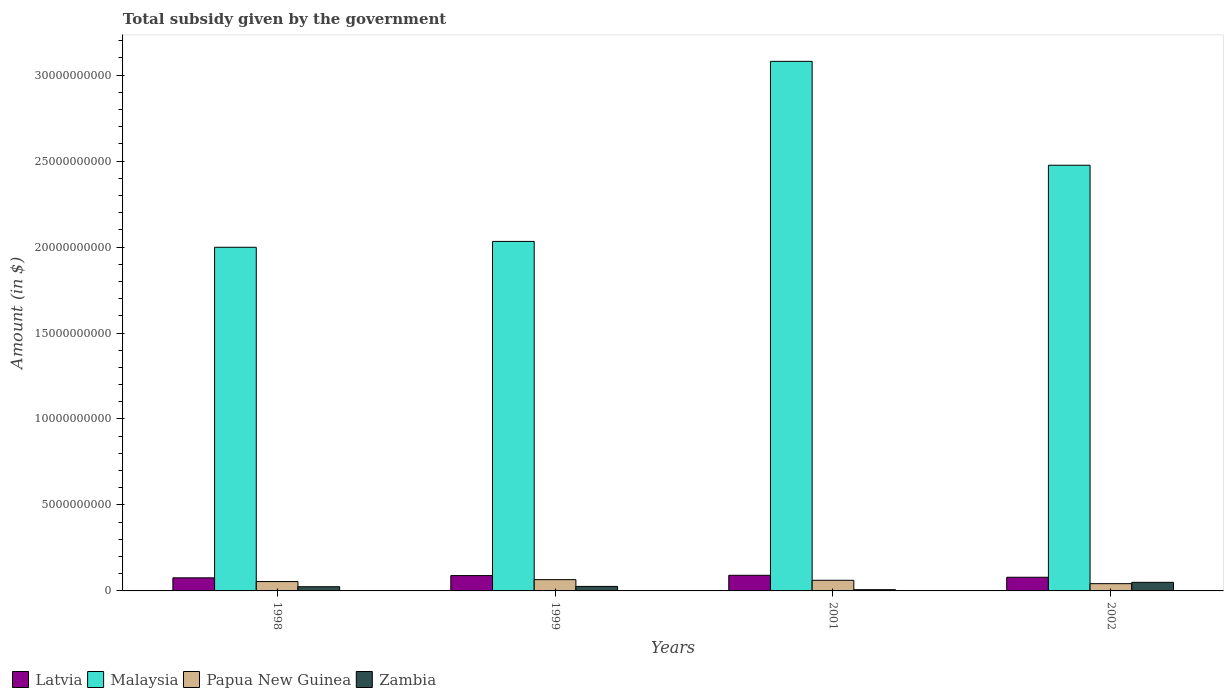How many different coloured bars are there?
Provide a succinct answer. 4. Are the number of bars per tick equal to the number of legend labels?
Ensure brevity in your answer.  Yes. In how many cases, is the number of bars for a given year not equal to the number of legend labels?
Your response must be concise. 0. What is the total revenue collected by the government in Latvia in 2002?
Offer a very short reply. 7.95e+08. Across all years, what is the maximum total revenue collected by the government in Malaysia?
Your answer should be very brief. 3.08e+1. Across all years, what is the minimum total revenue collected by the government in Zambia?
Offer a terse response. 7.21e+07. In which year was the total revenue collected by the government in Papua New Guinea maximum?
Offer a terse response. 1999. What is the total total revenue collected by the government in Malaysia in the graph?
Keep it short and to the point. 9.59e+1. What is the difference between the total revenue collected by the government in Papua New Guinea in 1999 and that in 2002?
Ensure brevity in your answer.  2.33e+08. What is the difference between the total revenue collected by the government in Latvia in 2002 and the total revenue collected by the government in Zambia in 1999?
Provide a succinct answer. 5.34e+08. What is the average total revenue collected by the government in Latvia per year?
Give a very brief answer. 8.39e+08. In the year 1999, what is the difference between the total revenue collected by the government in Malaysia and total revenue collected by the government in Papua New Guinea?
Make the answer very short. 1.97e+1. What is the ratio of the total revenue collected by the government in Malaysia in 1998 to that in 2002?
Your response must be concise. 0.81. Is the total revenue collected by the government in Latvia in 1998 less than that in 2001?
Make the answer very short. Yes. Is the difference between the total revenue collected by the government in Malaysia in 2001 and 2002 greater than the difference between the total revenue collected by the government in Papua New Guinea in 2001 and 2002?
Offer a terse response. Yes. What is the difference between the highest and the second highest total revenue collected by the government in Malaysia?
Provide a short and direct response. 6.04e+09. What is the difference between the highest and the lowest total revenue collected by the government in Papua New Guinea?
Make the answer very short. 2.33e+08. In how many years, is the total revenue collected by the government in Papua New Guinea greater than the average total revenue collected by the government in Papua New Guinea taken over all years?
Offer a very short reply. 2. What does the 3rd bar from the left in 2001 represents?
Your answer should be very brief. Papua New Guinea. What does the 4th bar from the right in 2002 represents?
Your answer should be compact. Latvia. Is it the case that in every year, the sum of the total revenue collected by the government in Latvia and total revenue collected by the government in Malaysia is greater than the total revenue collected by the government in Papua New Guinea?
Provide a short and direct response. Yes. How many bars are there?
Provide a succinct answer. 16. Are all the bars in the graph horizontal?
Provide a short and direct response. No. Does the graph contain any zero values?
Provide a succinct answer. No. Where does the legend appear in the graph?
Keep it short and to the point. Bottom left. What is the title of the graph?
Your answer should be very brief. Total subsidy given by the government. What is the label or title of the Y-axis?
Your response must be concise. Amount (in $). What is the Amount (in $) of Latvia in 1998?
Offer a terse response. 7.61e+08. What is the Amount (in $) of Malaysia in 1998?
Keep it short and to the point. 2.00e+1. What is the Amount (in $) of Papua New Guinea in 1998?
Keep it short and to the point. 5.45e+08. What is the Amount (in $) of Zambia in 1998?
Give a very brief answer. 2.44e+08. What is the Amount (in $) in Latvia in 1999?
Offer a very short reply. 8.92e+08. What is the Amount (in $) in Malaysia in 1999?
Your answer should be compact. 2.03e+1. What is the Amount (in $) in Papua New Guinea in 1999?
Your answer should be very brief. 6.56e+08. What is the Amount (in $) of Zambia in 1999?
Give a very brief answer. 2.62e+08. What is the Amount (in $) of Latvia in 2001?
Offer a terse response. 9.09e+08. What is the Amount (in $) of Malaysia in 2001?
Offer a terse response. 3.08e+1. What is the Amount (in $) of Papua New Guinea in 2001?
Keep it short and to the point. 6.18e+08. What is the Amount (in $) in Zambia in 2001?
Keep it short and to the point. 7.21e+07. What is the Amount (in $) in Latvia in 2002?
Offer a very short reply. 7.95e+08. What is the Amount (in $) in Malaysia in 2002?
Ensure brevity in your answer.  2.48e+1. What is the Amount (in $) of Papua New Guinea in 2002?
Give a very brief answer. 4.22e+08. What is the Amount (in $) in Zambia in 2002?
Your answer should be compact. 4.99e+08. Across all years, what is the maximum Amount (in $) of Latvia?
Keep it short and to the point. 9.09e+08. Across all years, what is the maximum Amount (in $) of Malaysia?
Offer a terse response. 3.08e+1. Across all years, what is the maximum Amount (in $) of Papua New Guinea?
Keep it short and to the point. 6.56e+08. Across all years, what is the maximum Amount (in $) in Zambia?
Ensure brevity in your answer.  4.99e+08. Across all years, what is the minimum Amount (in $) of Latvia?
Your response must be concise. 7.61e+08. Across all years, what is the minimum Amount (in $) in Malaysia?
Your response must be concise. 2.00e+1. Across all years, what is the minimum Amount (in $) in Papua New Guinea?
Offer a very short reply. 4.22e+08. Across all years, what is the minimum Amount (in $) of Zambia?
Make the answer very short. 7.21e+07. What is the total Amount (in $) of Latvia in the graph?
Your answer should be compact. 3.36e+09. What is the total Amount (in $) of Malaysia in the graph?
Your answer should be very brief. 9.59e+1. What is the total Amount (in $) in Papua New Guinea in the graph?
Keep it short and to the point. 2.24e+09. What is the total Amount (in $) of Zambia in the graph?
Your response must be concise. 1.08e+09. What is the difference between the Amount (in $) of Latvia in 1998 and that in 1999?
Ensure brevity in your answer.  -1.31e+08. What is the difference between the Amount (in $) of Malaysia in 1998 and that in 1999?
Give a very brief answer. -3.41e+08. What is the difference between the Amount (in $) in Papua New Guinea in 1998 and that in 1999?
Provide a short and direct response. -1.11e+08. What is the difference between the Amount (in $) of Zambia in 1998 and that in 1999?
Offer a terse response. -1.76e+07. What is the difference between the Amount (in $) in Latvia in 1998 and that in 2001?
Your answer should be very brief. -1.49e+08. What is the difference between the Amount (in $) of Malaysia in 1998 and that in 2001?
Provide a succinct answer. -1.08e+1. What is the difference between the Amount (in $) of Papua New Guinea in 1998 and that in 2001?
Your answer should be compact. -7.33e+07. What is the difference between the Amount (in $) of Zambia in 1998 and that in 2001?
Keep it short and to the point. 1.72e+08. What is the difference between the Amount (in $) of Latvia in 1998 and that in 2002?
Your answer should be compact. -3.44e+07. What is the difference between the Amount (in $) of Malaysia in 1998 and that in 2002?
Offer a terse response. -4.77e+09. What is the difference between the Amount (in $) of Papua New Guinea in 1998 and that in 2002?
Keep it short and to the point. 1.23e+08. What is the difference between the Amount (in $) in Zambia in 1998 and that in 2002?
Offer a very short reply. -2.55e+08. What is the difference between the Amount (in $) of Latvia in 1999 and that in 2001?
Provide a succinct answer. -1.75e+07. What is the difference between the Amount (in $) in Malaysia in 1999 and that in 2001?
Offer a terse response. -1.05e+1. What is the difference between the Amount (in $) in Papua New Guinea in 1999 and that in 2001?
Offer a terse response. 3.73e+07. What is the difference between the Amount (in $) of Zambia in 1999 and that in 2001?
Your response must be concise. 1.89e+08. What is the difference between the Amount (in $) of Latvia in 1999 and that in 2002?
Give a very brief answer. 9.67e+07. What is the difference between the Amount (in $) in Malaysia in 1999 and that in 2002?
Ensure brevity in your answer.  -4.43e+09. What is the difference between the Amount (in $) of Papua New Guinea in 1999 and that in 2002?
Give a very brief answer. 2.33e+08. What is the difference between the Amount (in $) of Zambia in 1999 and that in 2002?
Your answer should be compact. -2.38e+08. What is the difference between the Amount (in $) in Latvia in 2001 and that in 2002?
Offer a terse response. 1.14e+08. What is the difference between the Amount (in $) in Malaysia in 2001 and that in 2002?
Your answer should be very brief. 6.04e+09. What is the difference between the Amount (in $) in Papua New Guinea in 2001 and that in 2002?
Your response must be concise. 1.96e+08. What is the difference between the Amount (in $) in Zambia in 2001 and that in 2002?
Your answer should be compact. -4.27e+08. What is the difference between the Amount (in $) of Latvia in 1998 and the Amount (in $) of Malaysia in 1999?
Ensure brevity in your answer.  -1.96e+1. What is the difference between the Amount (in $) of Latvia in 1998 and the Amount (in $) of Papua New Guinea in 1999?
Provide a short and direct response. 1.05e+08. What is the difference between the Amount (in $) of Latvia in 1998 and the Amount (in $) of Zambia in 1999?
Make the answer very short. 4.99e+08. What is the difference between the Amount (in $) of Malaysia in 1998 and the Amount (in $) of Papua New Guinea in 1999?
Keep it short and to the point. 1.93e+1. What is the difference between the Amount (in $) of Malaysia in 1998 and the Amount (in $) of Zambia in 1999?
Provide a short and direct response. 1.97e+1. What is the difference between the Amount (in $) of Papua New Guinea in 1998 and the Amount (in $) of Zambia in 1999?
Your response must be concise. 2.84e+08. What is the difference between the Amount (in $) of Latvia in 1998 and the Amount (in $) of Malaysia in 2001?
Ensure brevity in your answer.  -3.00e+1. What is the difference between the Amount (in $) in Latvia in 1998 and the Amount (in $) in Papua New Guinea in 2001?
Keep it short and to the point. 1.42e+08. What is the difference between the Amount (in $) of Latvia in 1998 and the Amount (in $) of Zambia in 2001?
Your answer should be compact. 6.89e+08. What is the difference between the Amount (in $) of Malaysia in 1998 and the Amount (in $) of Papua New Guinea in 2001?
Your response must be concise. 1.94e+1. What is the difference between the Amount (in $) in Malaysia in 1998 and the Amount (in $) in Zambia in 2001?
Provide a short and direct response. 1.99e+1. What is the difference between the Amount (in $) in Papua New Guinea in 1998 and the Amount (in $) in Zambia in 2001?
Make the answer very short. 4.73e+08. What is the difference between the Amount (in $) of Latvia in 1998 and the Amount (in $) of Malaysia in 2002?
Make the answer very short. -2.40e+1. What is the difference between the Amount (in $) of Latvia in 1998 and the Amount (in $) of Papua New Guinea in 2002?
Keep it short and to the point. 3.38e+08. What is the difference between the Amount (in $) in Latvia in 1998 and the Amount (in $) in Zambia in 2002?
Your response must be concise. 2.61e+08. What is the difference between the Amount (in $) of Malaysia in 1998 and the Amount (in $) of Papua New Guinea in 2002?
Keep it short and to the point. 1.96e+1. What is the difference between the Amount (in $) of Malaysia in 1998 and the Amount (in $) of Zambia in 2002?
Provide a succinct answer. 1.95e+1. What is the difference between the Amount (in $) of Papua New Guinea in 1998 and the Amount (in $) of Zambia in 2002?
Keep it short and to the point. 4.58e+07. What is the difference between the Amount (in $) of Latvia in 1999 and the Amount (in $) of Malaysia in 2001?
Ensure brevity in your answer.  -2.99e+1. What is the difference between the Amount (in $) of Latvia in 1999 and the Amount (in $) of Papua New Guinea in 2001?
Offer a very short reply. 2.73e+08. What is the difference between the Amount (in $) of Latvia in 1999 and the Amount (in $) of Zambia in 2001?
Make the answer very short. 8.20e+08. What is the difference between the Amount (in $) in Malaysia in 1999 and the Amount (in $) in Papua New Guinea in 2001?
Ensure brevity in your answer.  1.97e+1. What is the difference between the Amount (in $) in Malaysia in 1999 and the Amount (in $) in Zambia in 2001?
Offer a terse response. 2.03e+1. What is the difference between the Amount (in $) of Papua New Guinea in 1999 and the Amount (in $) of Zambia in 2001?
Offer a terse response. 5.84e+08. What is the difference between the Amount (in $) of Latvia in 1999 and the Amount (in $) of Malaysia in 2002?
Make the answer very short. -2.39e+1. What is the difference between the Amount (in $) of Latvia in 1999 and the Amount (in $) of Papua New Guinea in 2002?
Provide a short and direct response. 4.70e+08. What is the difference between the Amount (in $) in Latvia in 1999 and the Amount (in $) in Zambia in 2002?
Ensure brevity in your answer.  3.93e+08. What is the difference between the Amount (in $) of Malaysia in 1999 and the Amount (in $) of Papua New Guinea in 2002?
Make the answer very short. 1.99e+1. What is the difference between the Amount (in $) in Malaysia in 1999 and the Amount (in $) in Zambia in 2002?
Your answer should be very brief. 1.98e+1. What is the difference between the Amount (in $) in Papua New Guinea in 1999 and the Amount (in $) in Zambia in 2002?
Your answer should be very brief. 1.56e+08. What is the difference between the Amount (in $) in Latvia in 2001 and the Amount (in $) in Malaysia in 2002?
Your answer should be compact. -2.38e+1. What is the difference between the Amount (in $) of Latvia in 2001 and the Amount (in $) of Papua New Guinea in 2002?
Provide a succinct answer. 4.87e+08. What is the difference between the Amount (in $) of Latvia in 2001 and the Amount (in $) of Zambia in 2002?
Give a very brief answer. 4.10e+08. What is the difference between the Amount (in $) in Malaysia in 2001 and the Amount (in $) in Papua New Guinea in 2002?
Your answer should be compact. 3.04e+1. What is the difference between the Amount (in $) of Malaysia in 2001 and the Amount (in $) of Zambia in 2002?
Keep it short and to the point. 3.03e+1. What is the difference between the Amount (in $) in Papua New Guinea in 2001 and the Amount (in $) in Zambia in 2002?
Your answer should be compact. 1.19e+08. What is the average Amount (in $) in Latvia per year?
Give a very brief answer. 8.39e+08. What is the average Amount (in $) of Malaysia per year?
Make the answer very short. 2.40e+1. What is the average Amount (in $) of Papua New Guinea per year?
Provide a short and direct response. 5.60e+08. What is the average Amount (in $) of Zambia per year?
Your response must be concise. 2.69e+08. In the year 1998, what is the difference between the Amount (in $) of Latvia and Amount (in $) of Malaysia?
Provide a short and direct response. -1.92e+1. In the year 1998, what is the difference between the Amount (in $) of Latvia and Amount (in $) of Papua New Guinea?
Offer a very short reply. 2.16e+08. In the year 1998, what is the difference between the Amount (in $) of Latvia and Amount (in $) of Zambia?
Provide a short and direct response. 5.17e+08. In the year 1998, what is the difference between the Amount (in $) of Malaysia and Amount (in $) of Papua New Guinea?
Your response must be concise. 1.94e+1. In the year 1998, what is the difference between the Amount (in $) in Malaysia and Amount (in $) in Zambia?
Make the answer very short. 1.97e+1. In the year 1998, what is the difference between the Amount (in $) of Papua New Guinea and Amount (in $) of Zambia?
Provide a short and direct response. 3.01e+08. In the year 1999, what is the difference between the Amount (in $) of Latvia and Amount (in $) of Malaysia?
Your response must be concise. -1.94e+1. In the year 1999, what is the difference between the Amount (in $) in Latvia and Amount (in $) in Papua New Guinea?
Keep it short and to the point. 2.36e+08. In the year 1999, what is the difference between the Amount (in $) of Latvia and Amount (in $) of Zambia?
Offer a terse response. 6.30e+08. In the year 1999, what is the difference between the Amount (in $) of Malaysia and Amount (in $) of Papua New Guinea?
Ensure brevity in your answer.  1.97e+1. In the year 1999, what is the difference between the Amount (in $) of Malaysia and Amount (in $) of Zambia?
Provide a succinct answer. 2.01e+1. In the year 1999, what is the difference between the Amount (in $) in Papua New Guinea and Amount (in $) in Zambia?
Your answer should be very brief. 3.94e+08. In the year 2001, what is the difference between the Amount (in $) in Latvia and Amount (in $) in Malaysia?
Offer a terse response. -2.99e+1. In the year 2001, what is the difference between the Amount (in $) of Latvia and Amount (in $) of Papua New Guinea?
Provide a short and direct response. 2.91e+08. In the year 2001, what is the difference between the Amount (in $) in Latvia and Amount (in $) in Zambia?
Provide a short and direct response. 8.37e+08. In the year 2001, what is the difference between the Amount (in $) in Malaysia and Amount (in $) in Papua New Guinea?
Your response must be concise. 3.02e+1. In the year 2001, what is the difference between the Amount (in $) in Malaysia and Amount (in $) in Zambia?
Make the answer very short. 3.07e+1. In the year 2001, what is the difference between the Amount (in $) in Papua New Guinea and Amount (in $) in Zambia?
Offer a terse response. 5.46e+08. In the year 2002, what is the difference between the Amount (in $) of Latvia and Amount (in $) of Malaysia?
Keep it short and to the point. -2.40e+1. In the year 2002, what is the difference between the Amount (in $) in Latvia and Amount (in $) in Papua New Guinea?
Ensure brevity in your answer.  3.73e+08. In the year 2002, what is the difference between the Amount (in $) of Latvia and Amount (in $) of Zambia?
Your response must be concise. 2.96e+08. In the year 2002, what is the difference between the Amount (in $) in Malaysia and Amount (in $) in Papua New Guinea?
Provide a short and direct response. 2.43e+1. In the year 2002, what is the difference between the Amount (in $) in Malaysia and Amount (in $) in Zambia?
Offer a terse response. 2.43e+1. In the year 2002, what is the difference between the Amount (in $) of Papua New Guinea and Amount (in $) of Zambia?
Give a very brief answer. -7.70e+07. What is the ratio of the Amount (in $) in Latvia in 1998 to that in 1999?
Give a very brief answer. 0.85. What is the ratio of the Amount (in $) of Malaysia in 1998 to that in 1999?
Keep it short and to the point. 0.98. What is the ratio of the Amount (in $) of Papua New Guinea in 1998 to that in 1999?
Make the answer very short. 0.83. What is the ratio of the Amount (in $) of Zambia in 1998 to that in 1999?
Provide a succinct answer. 0.93. What is the ratio of the Amount (in $) of Latvia in 1998 to that in 2001?
Make the answer very short. 0.84. What is the ratio of the Amount (in $) of Malaysia in 1998 to that in 2001?
Your response must be concise. 0.65. What is the ratio of the Amount (in $) of Papua New Guinea in 1998 to that in 2001?
Make the answer very short. 0.88. What is the ratio of the Amount (in $) in Zambia in 1998 to that in 2001?
Give a very brief answer. 3.38. What is the ratio of the Amount (in $) of Latvia in 1998 to that in 2002?
Offer a very short reply. 0.96. What is the ratio of the Amount (in $) in Malaysia in 1998 to that in 2002?
Offer a terse response. 0.81. What is the ratio of the Amount (in $) of Papua New Guinea in 1998 to that in 2002?
Provide a short and direct response. 1.29. What is the ratio of the Amount (in $) of Zambia in 1998 to that in 2002?
Make the answer very short. 0.49. What is the ratio of the Amount (in $) of Latvia in 1999 to that in 2001?
Make the answer very short. 0.98. What is the ratio of the Amount (in $) of Malaysia in 1999 to that in 2001?
Your answer should be compact. 0.66. What is the ratio of the Amount (in $) of Papua New Guinea in 1999 to that in 2001?
Make the answer very short. 1.06. What is the ratio of the Amount (in $) in Zambia in 1999 to that in 2001?
Your answer should be compact. 3.63. What is the ratio of the Amount (in $) of Latvia in 1999 to that in 2002?
Make the answer very short. 1.12. What is the ratio of the Amount (in $) of Malaysia in 1999 to that in 2002?
Keep it short and to the point. 0.82. What is the ratio of the Amount (in $) of Papua New Guinea in 1999 to that in 2002?
Your answer should be very brief. 1.55. What is the ratio of the Amount (in $) of Zambia in 1999 to that in 2002?
Your answer should be very brief. 0.52. What is the ratio of the Amount (in $) of Latvia in 2001 to that in 2002?
Ensure brevity in your answer.  1.14. What is the ratio of the Amount (in $) of Malaysia in 2001 to that in 2002?
Your answer should be very brief. 1.24. What is the ratio of the Amount (in $) in Papua New Guinea in 2001 to that in 2002?
Your answer should be compact. 1.46. What is the ratio of the Amount (in $) in Zambia in 2001 to that in 2002?
Make the answer very short. 0.14. What is the difference between the highest and the second highest Amount (in $) of Latvia?
Offer a very short reply. 1.75e+07. What is the difference between the highest and the second highest Amount (in $) of Malaysia?
Your response must be concise. 6.04e+09. What is the difference between the highest and the second highest Amount (in $) in Papua New Guinea?
Keep it short and to the point. 3.73e+07. What is the difference between the highest and the second highest Amount (in $) in Zambia?
Your response must be concise. 2.38e+08. What is the difference between the highest and the lowest Amount (in $) in Latvia?
Your answer should be very brief. 1.49e+08. What is the difference between the highest and the lowest Amount (in $) in Malaysia?
Your answer should be compact. 1.08e+1. What is the difference between the highest and the lowest Amount (in $) in Papua New Guinea?
Provide a short and direct response. 2.33e+08. What is the difference between the highest and the lowest Amount (in $) of Zambia?
Make the answer very short. 4.27e+08. 